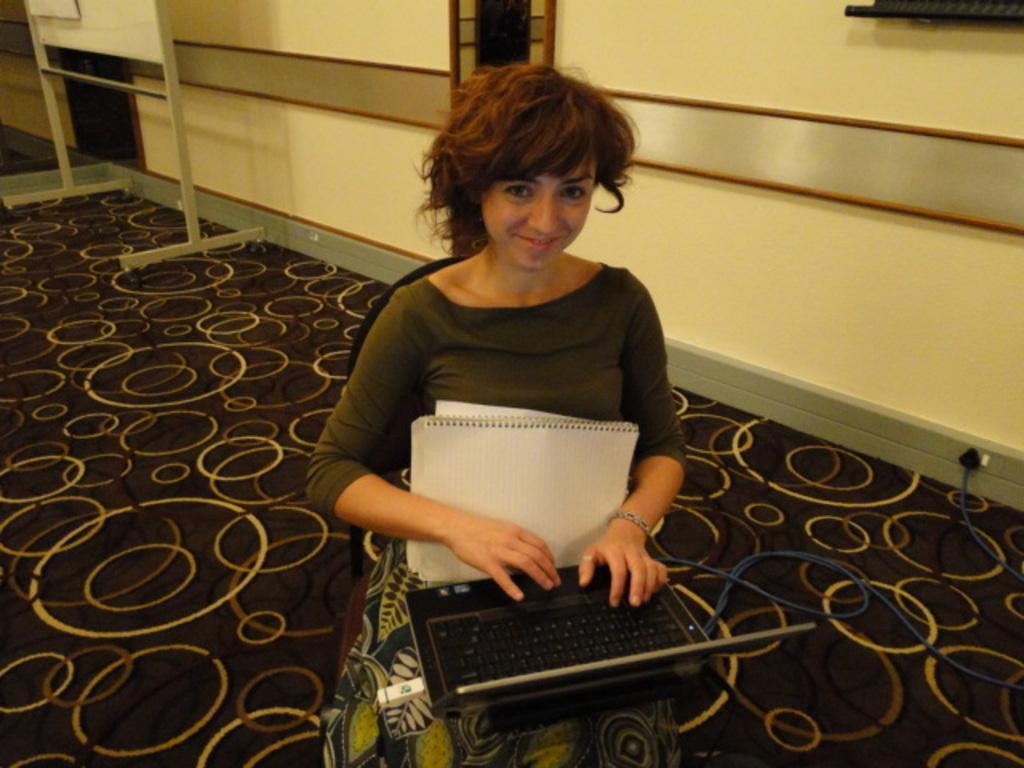In one or two sentences, can you explain what this image depicts? In this image one women sitting on a chair and working in a laptop along with her one book is there, beside her one wall is there , backside of her one board is there. 